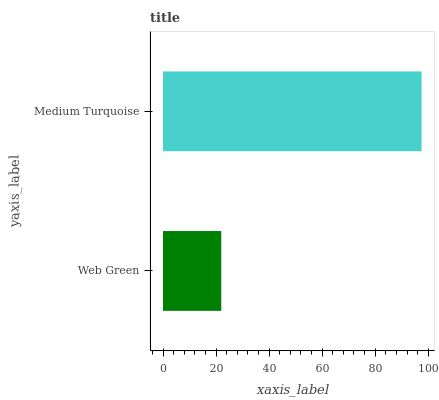Is Web Green the minimum?
Answer yes or no. Yes. Is Medium Turquoise the maximum?
Answer yes or no. Yes. Is Medium Turquoise the minimum?
Answer yes or no. No. Is Medium Turquoise greater than Web Green?
Answer yes or no. Yes. Is Web Green less than Medium Turquoise?
Answer yes or no. Yes. Is Web Green greater than Medium Turquoise?
Answer yes or no. No. Is Medium Turquoise less than Web Green?
Answer yes or no. No. Is Medium Turquoise the high median?
Answer yes or no. Yes. Is Web Green the low median?
Answer yes or no. Yes. Is Web Green the high median?
Answer yes or no. No. Is Medium Turquoise the low median?
Answer yes or no. No. 